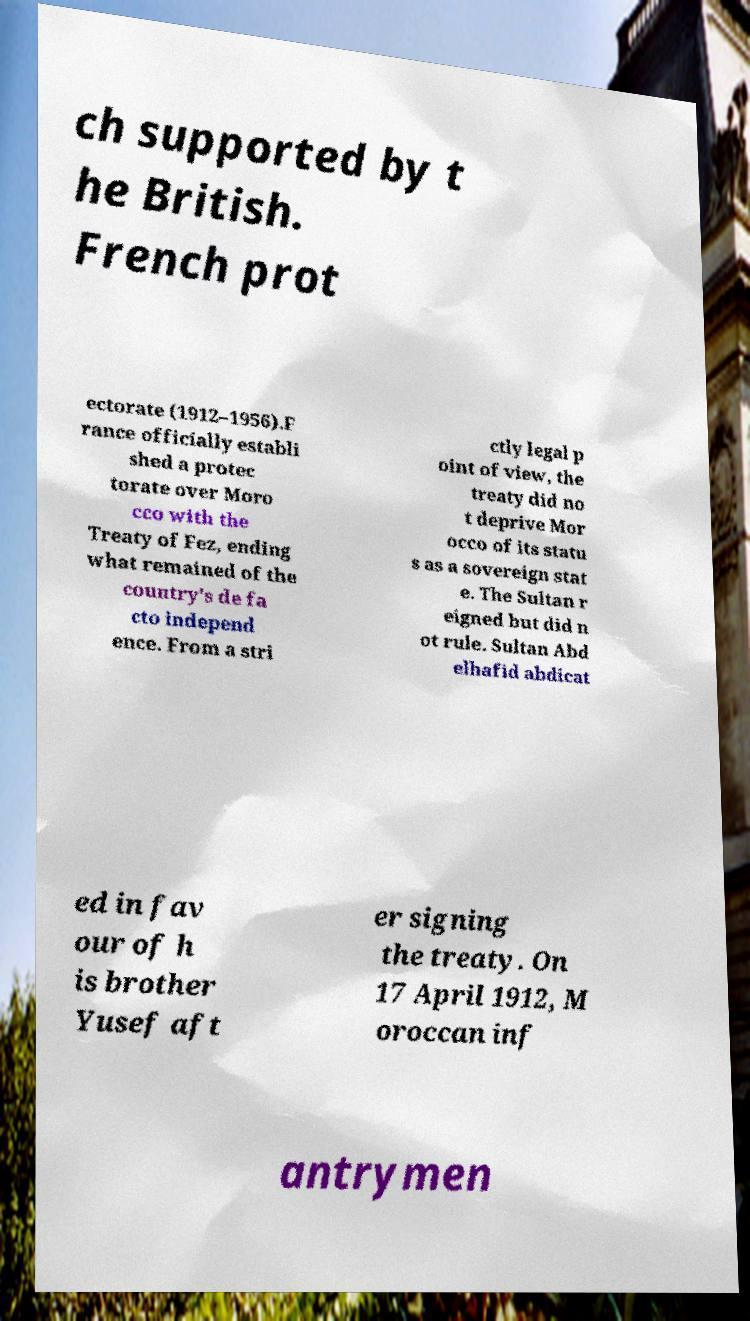Could you assist in decoding the text presented in this image and type it out clearly? ch supported by t he British. French prot ectorate (1912–1956).F rance officially establi shed a protec torate over Moro cco with the Treaty of Fez, ending what remained of the country's de fa cto independ ence. From a stri ctly legal p oint of view, the treaty did no t deprive Mor occo of its statu s as a sovereign stat e. The Sultan r eigned but did n ot rule. Sultan Abd elhafid abdicat ed in fav our of h is brother Yusef aft er signing the treaty. On 17 April 1912, M oroccan inf antrymen 